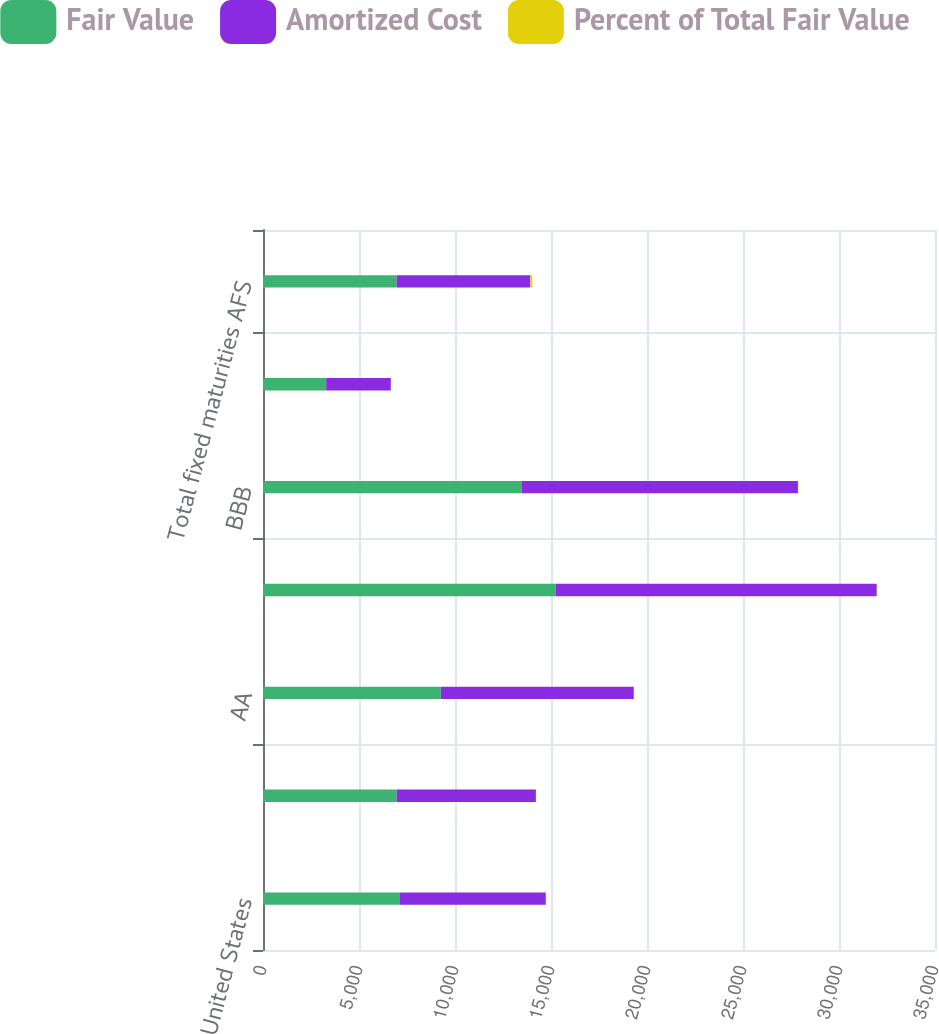Convert chart. <chart><loc_0><loc_0><loc_500><loc_500><stacked_bar_chart><ecel><fcel>United States<fcel>AAA<fcel>AA<fcel>A<fcel>BBB<fcel>BB & below<fcel>Total fixed maturities AFS<nl><fcel>Fair Value<fcel>7135<fcel>6963<fcel>9258<fcel>15250<fcel>13464<fcel>3292<fcel>6963<nl><fcel>Amortized Cost<fcel>7596<fcel>7251<fcel>10056<fcel>16717<fcel>14397<fcel>3367<fcel>6963<nl><fcel>Percent of Total Fair Value<fcel>12.8<fcel>12.2<fcel>16.9<fcel>28.2<fcel>24.2<fcel>5.7<fcel>100<nl></chart> 